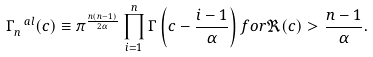Convert formula to latex. <formula><loc_0><loc_0><loc_500><loc_500>\Gamma _ { n } ^ { \ a l } ( c ) \equiv \pi ^ { \frac { n ( n - 1 ) } { 2 \alpha } } \prod _ { i = 1 } ^ { n } \Gamma \left ( c - \frac { i - 1 } { \alpha } \right ) f o r \Re ( c ) > \frac { n - 1 } { \alpha } .</formula> 